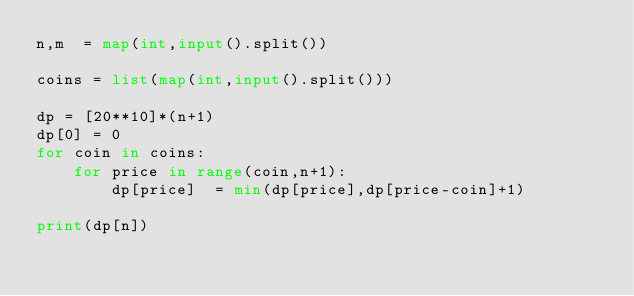Convert code to text. <code><loc_0><loc_0><loc_500><loc_500><_Python_>n,m  = map(int,input().split())

coins = list(map(int,input().split()))

dp = [20**10]*(n+1)
dp[0] = 0
for coin in coins:
    for price in range(coin,n+1):
        dp[price]  = min(dp[price],dp[price-coin]+1)
        
print(dp[n])
</code> 